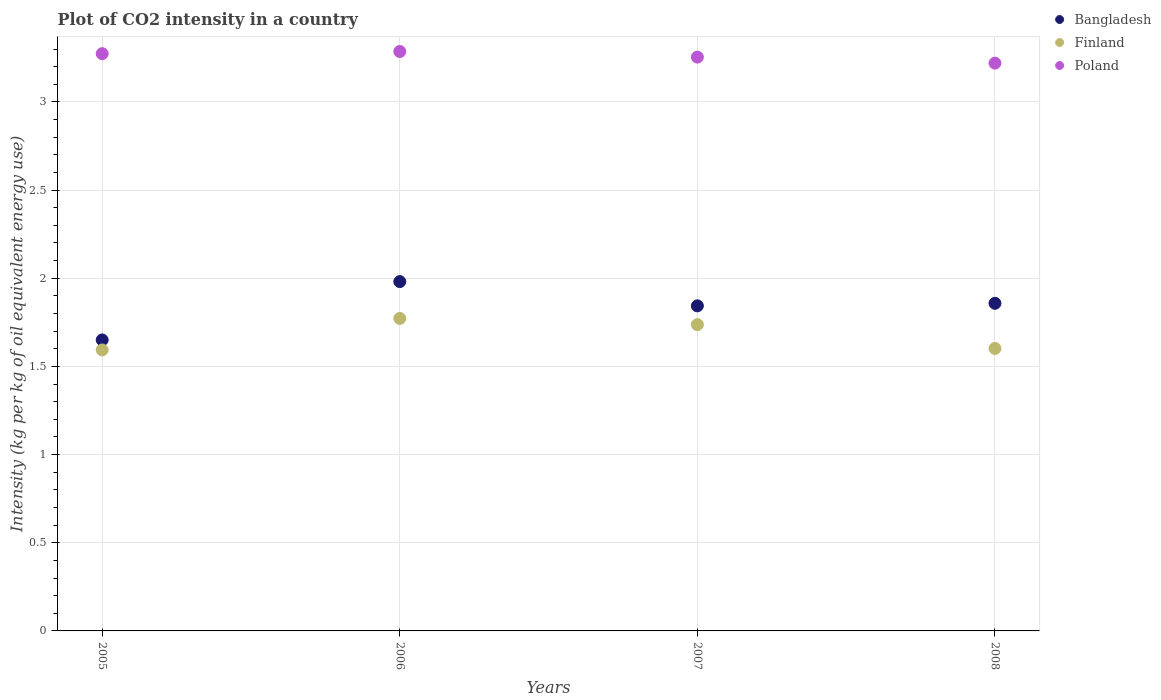What is the CO2 intensity in in Poland in 2006?
Offer a very short reply. 3.29. Across all years, what is the maximum CO2 intensity in in Finland?
Give a very brief answer. 1.77. Across all years, what is the minimum CO2 intensity in in Bangladesh?
Make the answer very short. 1.65. In which year was the CO2 intensity in in Finland minimum?
Offer a terse response. 2005. What is the total CO2 intensity in in Finland in the graph?
Your answer should be compact. 6.7. What is the difference between the CO2 intensity in in Finland in 2006 and that in 2007?
Offer a very short reply. 0.04. What is the difference between the CO2 intensity in in Finland in 2006 and the CO2 intensity in in Poland in 2007?
Your answer should be very brief. -1.48. What is the average CO2 intensity in in Finland per year?
Provide a short and direct response. 1.68. In the year 2006, what is the difference between the CO2 intensity in in Poland and CO2 intensity in in Bangladesh?
Your answer should be compact. 1.3. In how many years, is the CO2 intensity in in Bangladesh greater than 2.3 kg?
Ensure brevity in your answer.  0. What is the ratio of the CO2 intensity in in Finland in 2005 to that in 2006?
Give a very brief answer. 0.9. Is the CO2 intensity in in Bangladesh in 2005 less than that in 2007?
Ensure brevity in your answer.  Yes. What is the difference between the highest and the second highest CO2 intensity in in Poland?
Provide a succinct answer. 0.01. What is the difference between the highest and the lowest CO2 intensity in in Poland?
Offer a terse response. 0.07. How many years are there in the graph?
Your answer should be very brief. 4. Does the graph contain any zero values?
Your answer should be very brief. No. Where does the legend appear in the graph?
Offer a terse response. Top right. How many legend labels are there?
Provide a short and direct response. 3. What is the title of the graph?
Provide a succinct answer. Plot of CO2 intensity in a country. Does "Palau" appear as one of the legend labels in the graph?
Your response must be concise. No. What is the label or title of the Y-axis?
Provide a short and direct response. Intensity (kg per kg of oil equivalent energy use). What is the Intensity (kg per kg of oil equivalent energy use) in Bangladesh in 2005?
Give a very brief answer. 1.65. What is the Intensity (kg per kg of oil equivalent energy use) in Finland in 2005?
Your response must be concise. 1.59. What is the Intensity (kg per kg of oil equivalent energy use) in Poland in 2005?
Give a very brief answer. 3.27. What is the Intensity (kg per kg of oil equivalent energy use) of Bangladesh in 2006?
Keep it short and to the point. 1.98. What is the Intensity (kg per kg of oil equivalent energy use) in Finland in 2006?
Offer a terse response. 1.77. What is the Intensity (kg per kg of oil equivalent energy use) of Poland in 2006?
Your response must be concise. 3.29. What is the Intensity (kg per kg of oil equivalent energy use) in Bangladesh in 2007?
Provide a succinct answer. 1.84. What is the Intensity (kg per kg of oil equivalent energy use) in Finland in 2007?
Your answer should be compact. 1.74. What is the Intensity (kg per kg of oil equivalent energy use) in Poland in 2007?
Make the answer very short. 3.25. What is the Intensity (kg per kg of oil equivalent energy use) of Bangladesh in 2008?
Provide a succinct answer. 1.86. What is the Intensity (kg per kg of oil equivalent energy use) in Finland in 2008?
Your answer should be very brief. 1.6. What is the Intensity (kg per kg of oil equivalent energy use) in Poland in 2008?
Keep it short and to the point. 3.22. Across all years, what is the maximum Intensity (kg per kg of oil equivalent energy use) in Bangladesh?
Your answer should be very brief. 1.98. Across all years, what is the maximum Intensity (kg per kg of oil equivalent energy use) of Finland?
Provide a succinct answer. 1.77. Across all years, what is the maximum Intensity (kg per kg of oil equivalent energy use) in Poland?
Make the answer very short. 3.29. Across all years, what is the minimum Intensity (kg per kg of oil equivalent energy use) in Bangladesh?
Provide a short and direct response. 1.65. Across all years, what is the minimum Intensity (kg per kg of oil equivalent energy use) of Finland?
Your answer should be compact. 1.59. Across all years, what is the minimum Intensity (kg per kg of oil equivalent energy use) of Poland?
Give a very brief answer. 3.22. What is the total Intensity (kg per kg of oil equivalent energy use) in Bangladesh in the graph?
Keep it short and to the point. 7.33. What is the total Intensity (kg per kg of oil equivalent energy use) in Finland in the graph?
Your response must be concise. 6.7. What is the total Intensity (kg per kg of oil equivalent energy use) in Poland in the graph?
Give a very brief answer. 13.03. What is the difference between the Intensity (kg per kg of oil equivalent energy use) in Bangladesh in 2005 and that in 2006?
Ensure brevity in your answer.  -0.33. What is the difference between the Intensity (kg per kg of oil equivalent energy use) in Finland in 2005 and that in 2006?
Give a very brief answer. -0.18. What is the difference between the Intensity (kg per kg of oil equivalent energy use) of Poland in 2005 and that in 2006?
Your response must be concise. -0.01. What is the difference between the Intensity (kg per kg of oil equivalent energy use) of Bangladesh in 2005 and that in 2007?
Offer a terse response. -0.19. What is the difference between the Intensity (kg per kg of oil equivalent energy use) of Finland in 2005 and that in 2007?
Provide a short and direct response. -0.14. What is the difference between the Intensity (kg per kg of oil equivalent energy use) in Poland in 2005 and that in 2007?
Your answer should be very brief. 0.02. What is the difference between the Intensity (kg per kg of oil equivalent energy use) of Bangladesh in 2005 and that in 2008?
Provide a succinct answer. -0.21. What is the difference between the Intensity (kg per kg of oil equivalent energy use) of Finland in 2005 and that in 2008?
Keep it short and to the point. -0.01. What is the difference between the Intensity (kg per kg of oil equivalent energy use) of Poland in 2005 and that in 2008?
Your answer should be compact. 0.05. What is the difference between the Intensity (kg per kg of oil equivalent energy use) in Bangladesh in 2006 and that in 2007?
Provide a succinct answer. 0.14. What is the difference between the Intensity (kg per kg of oil equivalent energy use) in Finland in 2006 and that in 2007?
Give a very brief answer. 0.04. What is the difference between the Intensity (kg per kg of oil equivalent energy use) in Poland in 2006 and that in 2007?
Your response must be concise. 0.03. What is the difference between the Intensity (kg per kg of oil equivalent energy use) in Bangladesh in 2006 and that in 2008?
Offer a terse response. 0.12. What is the difference between the Intensity (kg per kg of oil equivalent energy use) of Finland in 2006 and that in 2008?
Your answer should be compact. 0.17. What is the difference between the Intensity (kg per kg of oil equivalent energy use) in Poland in 2006 and that in 2008?
Offer a very short reply. 0.07. What is the difference between the Intensity (kg per kg of oil equivalent energy use) in Bangladesh in 2007 and that in 2008?
Provide a succinct answer. -0.01. What is the difference between the Intensity (kg per kg of oil equivalent energy use) in Finland in 2007 and that in 2008?
Give a very brief answer. 0.14. What is the difference between the Intensity (kg per kg of oil equivalent energy use) of Poland in 2007 and that in 2008?
Make the answer very short. 0.03. What is the difference between the Intensity (kg per kg of oil equivalent energy use) of Bangladesh in 2005 and the Intensity (kg per kg of oil equivalent energy use) of Finland in 2006?
Make the answer very short. -0.12. What is the difference between the Intensity (kg per kg of oil equivalent energy use) in Bangladesh in 2005 and the Intensity (kg per kg of oil equivalent energy use) in Poland in 2006?
Provide a succinct answer. -1.64. What is the difference between the Intensity (kg per kg of oil equivalent energy use) of Finland in 2005 and the Intensity (kg per kg of oil equivalent energy use) of Poland in 2006?
Your answer should be compact. -1.69. What is the difference between the Intensity (kg per kg of oil equivalent energy use) in Bangladesh in 2005 and the Intensity (kg per kg of oil equivalent energy use) in Finland in 2007?
Your answer should be compact. -0.09. What is the difference between the Intensity (kg per kg of oil equivalent energy use) of Bangladesh in 2005 and the Intensity (kg per kg of oil equivalent energy use) of Poland in 2007?
Offer a terse response. -1.6. What is the difference between the Intensity (kg per kg of oil equivalent energy use) of Finland in 2005 and the Intensity (kg per kg of oil equivalent energy use) of Poland in 2007?
Offer a terse response. -1.66. What is the difference between the Intensity (kg per kg of oil equivalent energy use) in Bangladesh in 2005 and the Intensity (kg per kg of oil equivalent energy use) in Finland in 2008?
Your response must be concise. 0.05. What is the difference between the Intensity (kg per kg of oil equivalent energy use) in Bangladesh in 2005 and the Intensity (kg per kg of oil equivalent energy use) in Poland in 2008?
Your answer should be compact. -1.57. What is the difference between the Intensity (kg per kg of oil equivalent energy use) of Finland in 2005 and the Intensity (kg per kg of oil equivalent energy use) of Poland in 2008?
Keep it short and to the point. -1.63. What is the difference between the Intensity (kg per kg of oil equivalent energy use) of Bangladesh in 2006 and the Intensity (kg per kg of oil equivalent energy use) of Finland in 2007?
Your answer should be very brief. 0.24. What is the difference between the Intensity (kg per kg of oil equivalent energy use) in Bangladesh in 2006 and the Intensity (kg per kg of oil equivalent energy use) in Poland in 2007?
Your answer should be compact. -1.27. What is the difference between the Intensity (kg per kg of oil equivalent energy use) in Finland in 2006 and the Intensity (kg per kg of oil equivalent energy use) in Poland in 2007?
Your answer should be very brief. -1.48. What is the difference between the Intensity (kg per kg of oil equivalent energy use) in Bangladesh in 2006 and the Intensity (kg per kg of oil equivalent energy use) in Finland in 2008?
Offer a terse response. 0.38. What is the difference between the Intensity (kg per kg of oil equivalent energy use) in Bangladesh in 2006 and the Intensity (kg per kg of oil equivalent energy use) in Poland in 2008?
Ensure brevity in your answer.  -1.24. What is the difference between the Intensity (kg per kg of oil equivalent energy use) in Finland in 2006 and the Intensity (kg per kg of oil equivalent energy use) in Poland in 2008?
Offer a terse response. -1.45. What is the difference between the Intensity (kg per kg of oil equivalent energy use) of Bangladesh in 2007 and the Intensity (kg per kg of oil equivalent energy use) of Finland in 2008?
Provide a succinct answer. 0.24. What is the difference between the Intensity (kg per kg of oil equivalent energy use) in Bangladesh in 2007 and the Intensity (kg per kg of oil equivalent energy use) in Poland in 2008?
Provide a short and direct response. -1.38. What is the difference between the Intensity (kg per kg of oil equivalent energy use) of Finland in 2007 and the Intensity (kg per kg of oil equivalent energy use) of Poland in 2008?
Your answer should be very brief. -1.48. What is the average Intensity (kg per kg of oil equivalent energy use) of Bangladesh per year?
Your answer should be compact. 1.83. What is the average Intensity (kg per kg of oil equivalent energy use) in Finland per year?
Ensure brevity in your answer.  1.68. What is the average Intensity (kg per kg of oil equivalent energy use) of Poland per year?
Offer a terse response. 3.26. In the year 2005, what is the difference between the Intensity (kg per kg of oil equivalent energy use) in Bangladesh and Intensity (kg per kg of oil equivalent energy use) in Finland?
Keep it short and to the point. 0.06. In the year 2005, what is the difference between the Intensity (kg per kg of oil equivalent energy use) of Bangladesh and Intensity (kg per kg of oil equivalent energy use) of Poland?
Ensure brevity in your answer.  -1.62. In the year 2005, what is the difference between the Intensity (kg per kg of oil equivalent energy use) in Finland and Intensity (kg per kg of oil equivalent energy use) in Poland?
Provide a short and direct response. -1.68. In the year 2006, what is the difference between the Intensity (kg per kg of oil equivalent energy use) in Bangladesh and Intensity (kg per kg of oil equivalent energy use) in Finland?
Keep it short and to the point. 0.21. In the year 2006, what is the difference between the Intensity (kg per kg of oil equivalent energy use) of Bangladesh and Intensity (kg per kg of oil equivalent energy use) of Poland?
Offer a terse response. -1.3. In the year 2006, what is the difference between the Intensity (kg per kg of oil equivalent energy use) in Finland and Intensity (kg per kg of oil equivalent energy use) in Poland?
Provide a short and direct response. -1.51. In the year 2007, what is the difference between the Intensity (kg per kg of oil equivalent energy use) of Bangladesh and Intensity (kg per kg of oil equivalent energy use) of Finland?
Ensure brevity in your answer.  0.11. In the year 2007, what is the difference between the Intensity (kg per kg of oil equivalent energy use) in Bangladesh and Intensity (kg per kg of oil equivalent energy use) in Poland?
Provide a succinct answer. -1.41. In the year 2007, what is the difference between the Intensity (kg per kg of oil equivalent energy use) of Finland and Intensity (kg per kg of oil equivalent energy use) of Poland?
Offer a very short reply. -1.52. In the year 2008, what is the difference between the Intensity (kg per kg of oil equivalent energy use) of Bangladesh and Intensity (kg per kg of oil equivalent energy use) of Finland?
Keep it short and to the point. 0.26. In the year 2008, what is the difference between the Intensity (kg per kg of oil equivalent energy use) of Bangladesh and Intensity (kg per kg of oil equivalent energy use) of Poland?
Make the answer very short. -1.36. In the year 2008, what is the difference between the Intensity (kg per kg of oil equivalent energy use) of Finland and Intensity (kg per kg of oil equivalent energy use) of Poland?
Your answer should be very brief. -1.62. What is the ratio of the Intensity (kg per kg of oil equivalent energy use) in Bangladesh in 2005 to that in 2006?
Give a very brief answer. 0.83. What is the ratio of the Intensity (kg per kg of oil equivalent energy use) of Finland in 2005 to that in 2006?
Your response must be concise. 0.9. What is the ratio of the Intensity (kg per kg of oil equivalent energy use) of Poland in 2005 to that in 2006?
Ensure brevity in your answer.  1. What is the ratio of the Intensity (kg per kg of oil equivalent energy use) of Bangladesh in 2005 to that in 2007?
Offer a very short reply. 0.9. What is the ratio of the Intensity (kg per kg of oil equivalent energy use) in Finland in 2005 to that in 2007?
Make the answer very short. 0.92. What is the ratio of the Intensity (kg per kg of oil equivalent energy use) in Poland in 2005 to that in 2007?
Your answer should be compact. 1.01. What is the ratio of the Intensity (kg per kg of oil equivalent energy use) of Bangladesh in 2005 to that in 2008?
Provide a succinct answer. 0.89. What is the ratio of the Intensity (kg per kg of oil equivalent energy use) of Poland in 2005 to that in 2008?
Ensure brevity in your answer.  1.02. What is the ratio of the Intensity (kg per kg of oil equivalent energy use) in Bangladesh in 2006 to that in 2007?
Give a very brief answer. 1.07. What is the ratio of the Intensity (kg per kg of oil equivalent energy use) in Finland in 2006 to that in 2007?
Your answer should be compact. 1.02. What is the ratio of the Intensity (kg per kg of oil equivalent energy use) of Poland in 2006 to that in 2007?
Ensure brevity in your answer.  1.01. What is the ratio of the Intensity (kg per kg of oil equivalent energy use) of Bangladesh in 2006 to that in 2008?
Keep it short and to the point. 1.07. What is the ratio of the Intensity (kg per kg of oil equivalent energy use) in Finland in 2006 to that in 2008?
Provide a succinct answer. 1.11. What is the ratio of the Intensity (kg per kg of oil equivalent energy use) in Poland in 2006 to that in 2008?
Keep it short and to the point. 1.02. What is the ratio of the Intensity (kg per kg of oil equivalent energy use) in Finland in 2007 to that in 2008?
Ensure brevity in your answer.  1.08. What is the ratio of the Intensity (kg per kg of oil equivalent energy use) in Poland in 2007 to that in 2008?
Make the answer very short. 1.01. What is the difference between the highest and the second highest Intensity (kg per kg of oil equivalent energy use) in Bangladesh?
Provide a succinct answer. 0.12. What is the difference between the highest and the second highest Intensity (kg per kg of oil equivalent energy use) in Finland?
Make the answer very short. 0.04. What is the difference between the highest and the second highest Intensity (kg per kg of oil equivalent energy use) of Poland?
Give a very brief answer. 0.01. What is the difference between the highest and the lowest Intensity (kg per kg of oil equivalent energy use) in Bangladesh?
Offer a terse response. 0.33. What is the difference between the highest and the lowest Intensity (kg per kg of oil equivalent energy use) of Finland?
Your answer should be compact. 0.18. What is the difference between the highest and the lowest Intensity (kg per kg of oil equivalent energy use) in Poland?
Offer a very short reply. 0.07. 